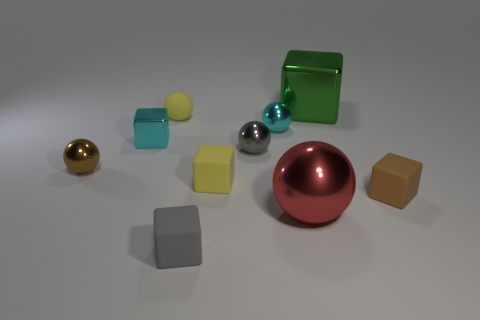Is the red metallic thing the same shape as the gray matte thing?
Provide a short and direct response. No. There is a tiny gray thing in front of the brown rubber thing; how many small cyan objects are to the left of it?
Give a very brief answer. 1. What number of blocks are behind the small cyan metallic block and left of the large metallic sphere?
Make the answer very short. 0. How many objects are matte objects or cyan spheres that are right of the yellow matte block?
Give a very brief answer. 5. The brown cube that is made of the same material as the tiny yellow cube is what size?
Your response must be concise. Small. What is the shape of the rubber object behind the cyan thing that is to the right of the yellow block?
Make the answer very short. Sphere. What number of cyan things are big spheres or large shiny cubes?
Keep it short and to the point. 0. Is there a small gray metallic ball that is in front of the small yellow matte thing to the right of the gray thing left of the yellow matte cube?
Your answer should be very brief. No. What is the shape of the tiny rubber thing that is the same color as the small matte sphere?
Your response must be concise. Cube. What number of big things are either yellow metallic cubes or brown metallic objects?
Keep it short and to the point. 0. 